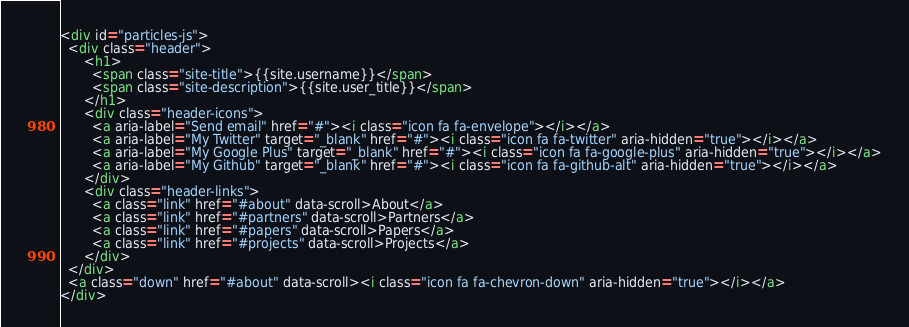<code> <loc_0><loc_0><loc_500><loc_500><_HTML_><div id="particles-js">
  <div class="header">
      <h1>
        <span class="site-title">{{site.username}}</span>
        <span class="site-description">{{site.user_title}}</span>
      </h1>
      <div class="header-icons">
        <a aria-label="Send email" href="#"><i class="icon fa fa-envelope"></i></a>
        <a aria-label="My Twitter" target="_blank" href="#"><i class="icon fa fa-twitter" aria-hidden="true"></i></a>
        <a aria-label="My Google Plus" target="_blank" href="#"><i class="icon fa fa-google-plus" aria-hidden="true"></i></a>
        <a aria-label="My Github" target="_blank" href="#"><i class="icon fa fa-github-alt" aria-hidden="true"></i></a>
      </div>
      <div class="header-links">
        <a class="link" href="#about" data-scroll>About</a>
        <a class="link" href="#partners" data-scroll>Partners</a>
        <a class="link" href="#papers" data-scroll>Papers</a>
        <a class="link" href="#projects" data-scroll>Projects</a>
      </div>
  </div>
  <a class="down" href="#about" data-scroll><i class="icon fa fa-chevron-down" aria-hidden="true"></i></a>
</div>
</code> 